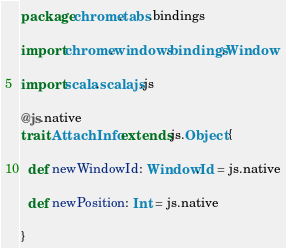<code> <loc_0><loc_0><loc_500><loc_500><_Scala_>package chrome.tabs.bindings

import chrome.windows.bindings.Window

import scala.scalajs.js

@js.native
trait AttachInfo extends js.Object {

  def newWindowId: Window.Id = js.native

  def newPosition: Int = js.native

}
</code> 